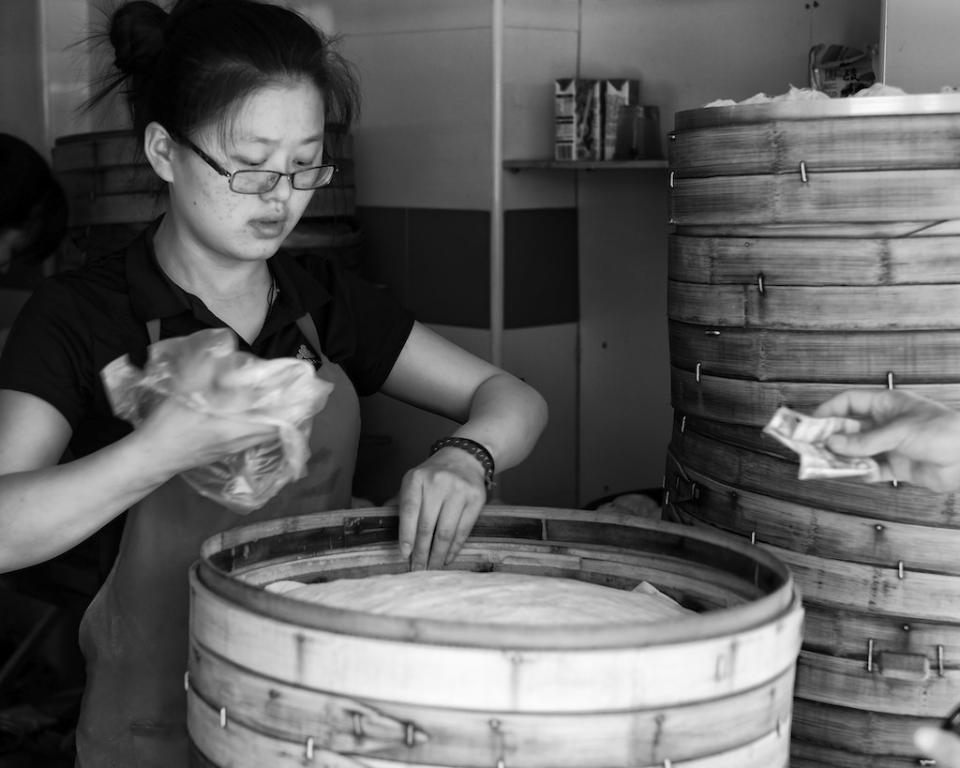How would you summarize this image in a sentence or two? Here in this picture we can see a woman standing over a place and we can see she is wearing an apron and spectacles and carrying a cover in her hand and in front of her we can see a box with some thing filled in it and beside that also we can see same boxes present and we can see another person's hand holding something and behind her we can see some things present in the rack. 